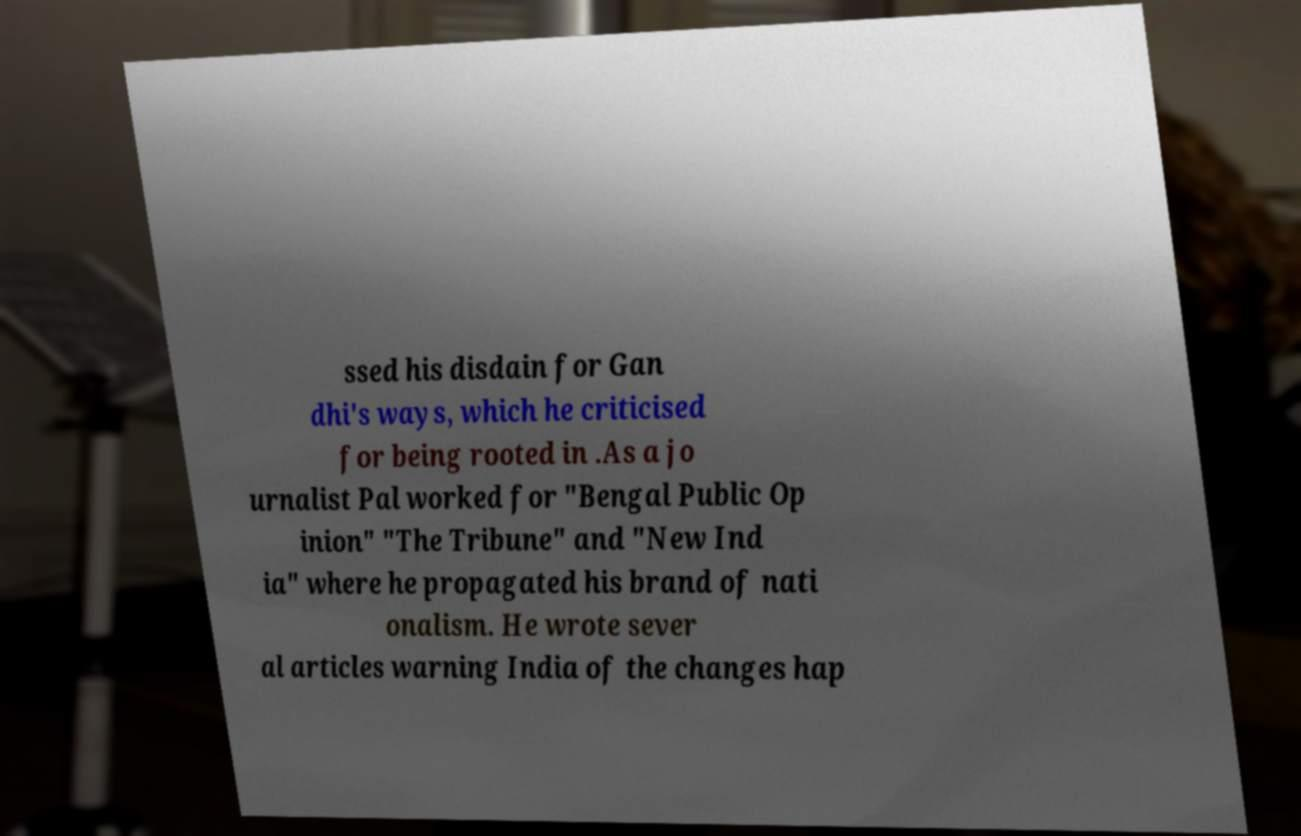Can you accurately transcribe the text from the provided image for me? ssed his disdain for Gan dhi's ways, which he criticised for being rooted in .As a jo urnalist Pal worked for "Bengal Public Op inion" "The Tribune" and "New Ind ia" where he propagated his brand of nati onalism. He wrote sever al articles warning India of the changes hap 